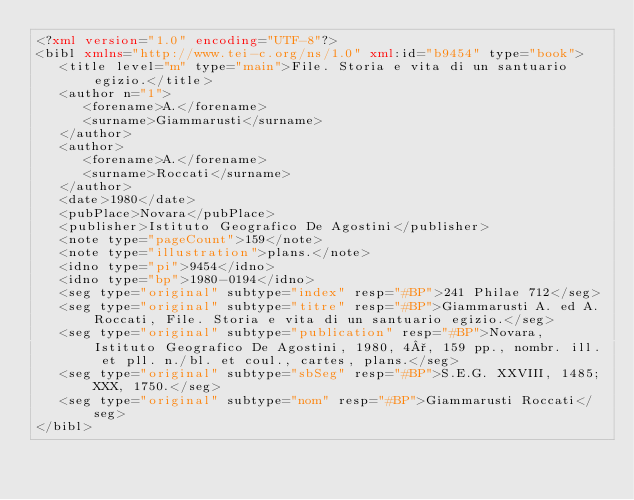Convert code to text. <code><loc_0><loc_0><loc_500><loc_500><_XML_><?xml version="1.0" encoding="UTF-8"?>
<bibl xmlns="http://www.tei-c.org/ns/1.0" xml:id="b9454" type="book">
   <title level="m" type="main">File. Storia e vita di un santuario egizio.</title>
   <author n="1">
      <forename>A.</forename>
      <surname>Giammarusti</surname>
   </author>
   <author>
      <forename>A.</forename>
      <surname>Roccati</surname>
   </author>
   <date>1980</date>
   <pubPlace>Novara</pubPlace>
   <publisher>Istituto Geografico De Agostini</publisher>
   <note type="pageCount">159</note>
   <note type="illustration">plans.</note>
   <idno type="pi">9454</idno>
   <idno type="bp">1980-0194</idno>
   <seg type="original" subtype="index" resp="#BP">241 Philae 712</seg>
   <seg type="original" subtype="titre" resp="#BP">Giammarusti A. ed A. Roccati, File. Storia e vita di un santuario egizio.</seg>
   <seg type="original" subtype="publication" resp="#BP">Novara, Istituto Geografico De Agostini, 1980, 4°, 159 pp., nombr. ill. et pll. n./bl. et coul., cartes, plans.</seg>
   <seg type="original" subtype="sbSeg" resp="#BP">S.E.G. XXVIII, 1485; XXX, 1750.</seg>
   <seg type="original" subtype="nom" resp="#BP">Giammarusti Roccati</seg>
</bibl>
</code> 